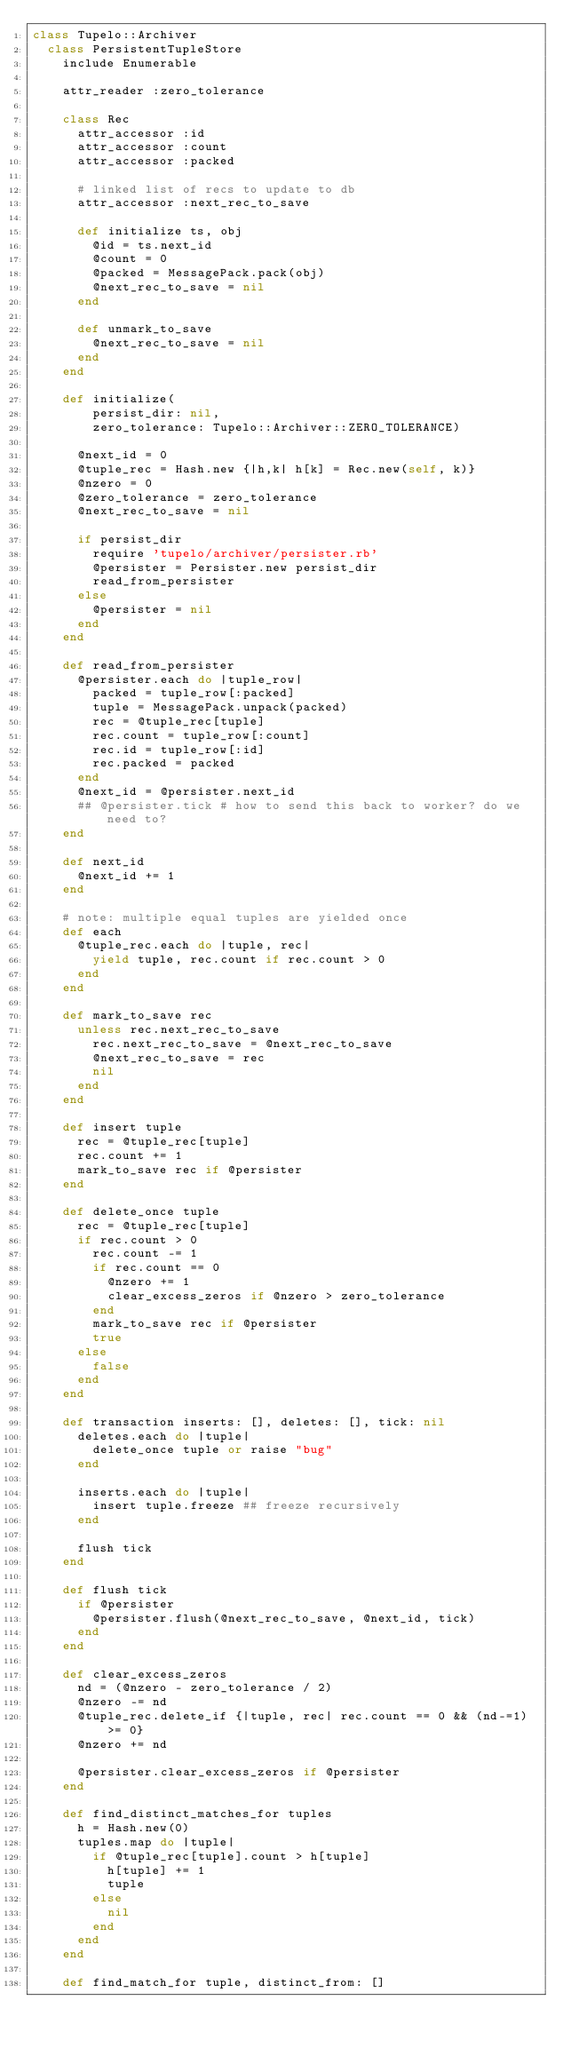<code> <loc_0><loc_0><loc_500><loc_500><_Ruby_>class Tupelo::Archiver
  class PersistentTupleStore
    include Enumerable
    
    attr_reader :zero_tolerance
    
    class Rec
      attr_accessor :id
      attr_accessor :count
      attr_accessor :packed
      
      # linked list of recs to update to db
      attr_accessor :next_rec_to_save
      
      def initialize ts, obj
        @id = ts.next_id
        @count = 0
        @packed = MessagePack.pack(obj)
        @next_rec_to_save = nil
      end
      
      def unmark_to_save
        @next_rec_to_save = nil
      end
    end

    def initialize(
        persist_dir: nil,
        zero_tolerance: Tupelo::Archiver::ZERO_TOLERANCE)

      @next_id = 0
      @tuple_rec = Hash.new {|h,k| h[k] = Rec.new(self, k)}
      @nzero = 0
      @zero_tolerance = zero_tolerance
      @next_rec_to_save = nil

      if persist_dir
        require 'tupelo/archiver/persister.rb'
        @persister = Persister.new persist_dir
        read_from_persister
      else
        @persister = nil
      end
    end

    def read_from_persister
      @persister.each do |tuple_row|
        packed = tuple_row[:packed]
        tuple = MessagePack.unpack(packed)
        rec = @tuple_rec[tuple]
        rec.count = tuple_row[:count]
        rec.id = tuple_row[:id]
        rec.packed = packed
      end
      @next_id = @persister.next_id
      ## @persister.tick # how to send this back to worker? do we need to?
    end

    def next_id
      @next_id += 1
    end
    
    # note: multiple equal tuples are yielded once
    def each
      @tuple_rec.each do |tuple, rec|
        yield tuple, rec.count if rec.count > 0
      end
    end
    
    def mark_to_save rec
      unless rec.next_rec_to_save
        rec.next_rec_to_save = @next_rec_to_save
        @next_rec_to_save = rec
        nil
      end
    end

    def insert tuple
      rec = @tuple_rec[tuple]
      rec.count += 1
      mark_to_save rec if @persister
    end
    
    def delete_once tuple
      rec = @tuple_rec[tuple]
      if rec.count > 0
        rec.count -= 1
        if rec.count == 0
          @nzero += 1
          clear_excess_zeros if @nzero > zero_tolerance
        end
        mark_to_save rec if @persister
        true
      else
        false
      end
    end

    def transaction inserts: [], deletes: [], tick: nil
      deletes.each do |tuple|
        delete_once tuple or raise "bug"
      end

      inserts.each do |tuple|
        insert tuple.freeze ## freeze recursively
      end
      
      flush tick
    end

    def flush tick
      if @persister
        @persister.flush(@next_rec_to_save, @next_id, tick)
      end
    end

    def clear_excess_zeros
      nd = (@nzero - zero_tolerance / 2)
      @nzero -= nd
      @tuple_rec.delete_if {|tuple, rec| rec.count == 0 && (nd-=1) >= 0}
      @nzero += nd
      
      @persister.clear_excess_zeros if @persister
    end

    def find_distinct_matches_for tuples
      h = Hash.new(0)
      tuples.map do |tuple|
        if @tuple_rec[tuple].count > h[tuple]
          h[tuple] += 1
          tuple
        else
          nil
        end
      end
    end

    def find_match_for tuple, distinct_from: []</code> 